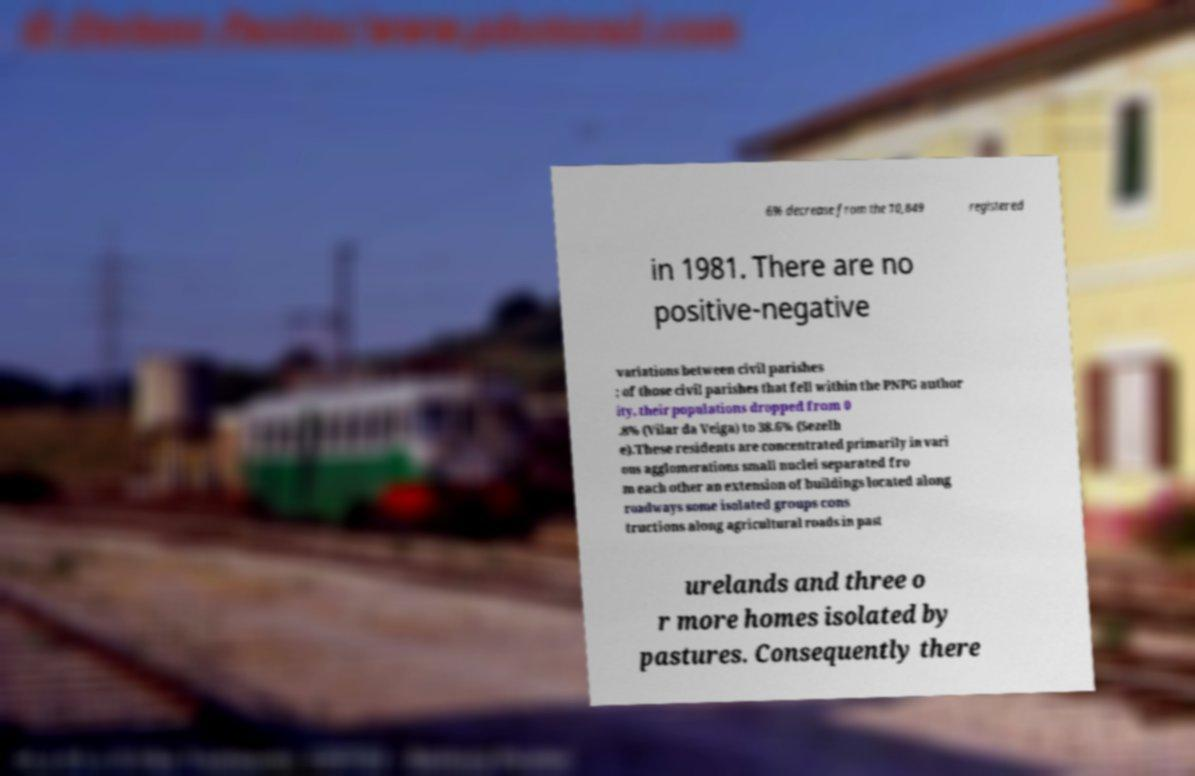There's text embedded in this image that I need extracted. Can you transcribe it verbatim? 6% decrease from the 10,849 registered in 1981. There are no positive-negative variations between civil parishes ; of those civil parishes that fell within the PNPG author ity, their populations dropped from 0 .8% (Vilar da Veiga) to 38.6% (Sezelh e).These residents are concentrated primarily in vari ous agglomerations small nuclei separated fro m each other an extension of buildings located along roadways some isolated groups cons tructions along agricultural roads in past urelands and three o r more homes isolated by pastures. Consequently there 